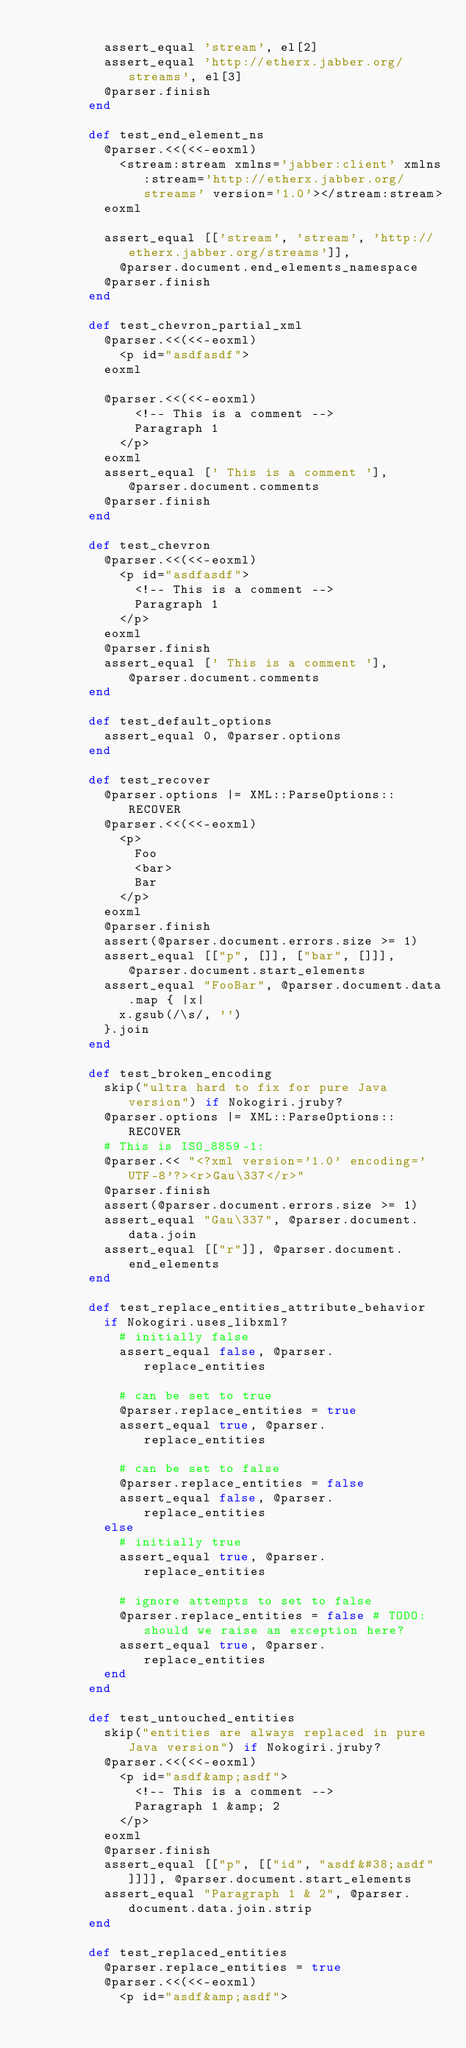Convert code to text. <code><loc_0><loc_0><loc_500><loc_500><_Ruby_>
          assert_equal 'stream', el[2]
          assert_equal 'http://etherx.jabber.org/streams', el[3]
          @parser.finish
        end

        def test_end_element_ns
          @parser.<<(<<-eoxml)
            <stream:stream xmlns='jabber:client' xmlns:stream='http://etherx.jabber.org/streams' version='1.0'></stream:stream>
          eoxml

          assert_equal [['stream', 'stream', 'http://etherx.jabber.org/streams']],
            @parser.document.end_elements_namespace
          @parser.finish
        end

        def test_chevron_partial_xml
          @parser.<<(<<-eoxml)
            <p id="asdfasdf">
          eoxml

          @parser.<<(<<-eoxml)
              <!-- This is a comment -->
              Paragraph 1
            </p>
          eoxml
          assert_equal [' This is a comment '], @parser.document.comments
          @parser.finish
        end

        def test_chevron
          @parser.<<(<<-eoxml)
            <p id="asdfasdf">
              <!-- This is a comment -->
              Paragraph 1
            </p>
          eoxml
          @parser.finish
          assert_equal [' This is a comment '], @parser.document.comments
        end

        def test_default_options
          assert_equal 0, @parser.options
        end

        def test_recover
          @parser.options |= XML::ParseOptions::RECOVER
          @parser.<<(<<-eoxml)
            <p>
              Foo
              <bar>
              Bar
            </p>
          eoxml
          @parser.finish
          assert(@parser.document.errors.size >= 1)
          assert_equal [["p", []], ["bar", []]], @parser.document.start_elements
          assert_equal "FooBar", @parser.document.data.map { |x|
            x.gsub(/\s/, '')
          }.join
        end

        def test_broken_encoding
          skip("ultra hard to fix for pure Java version") if Nokogiri.jruby?
          @parser.options |= XML::ParseOptions::RECOVER
          # This is ISO_8859-1:
          @parser.<< "<?xml version='1.0' encoding='UTF-8'?><r>Gau\337</r>"
          @parser.finish
          assert(@parser.document.errors.size >= 1)
          assert_equal "Gau\337", @parser.document.data.join
          assert_equal [["r"]], @parser.document.end_elements
        end

        def test_replace_entities_attribute_behavior
          if Nokogiri.uses_libxml?
            # initially false
            assert_equal false, @parser.replace_entities

            # can be set to true
            @parser.replace_entities = true
            assert_equal true, @parser.replace_entities

            # can be set to false
            @parser.replace_entities = false
            assert_equal false, @parser.replace_entities
          else
            # initially true
            assert_equal true, @parser.replace_entities

            # ignore attempts to set to false
            @parser.replace_entities = false # TODO: should we raise an exception here?
            assert_equal true, @parser.replace_entities
          end
        end

        def test_untouched_entities
          skip("entities are always replaced in pure Java version") if Nokogiri.jruby?
          @parser.<<(<<-eoxml)
            <p id="asdf&amp;asdf">
              <!-- This is a comment -->
              Paragraph 1 &amp; 2
            </p>
          eoxml
          @parser.finish
          assert_equal [["p", [["id", "asdf&#38;asdf"]]]], @parser.document.start_elements
          assert_equal "Paragraph 1 & 2", @parser.document.data.join.strip
        end

        def test_replaced_entities
          @parser.replace_entities = true
          @parser.<<(<<-eoxml)
            <p id="asdf&amp;asdf"></code> 